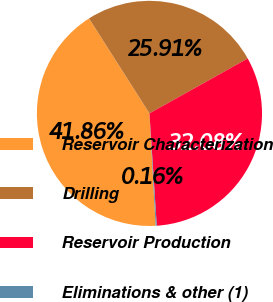<chart> <loc_0><loc_0><loc_500><loc_500><pie_chart><fcel>Reservoir Characterization<fcel>Drilling<fcel>Reservoir Production<fcel>Eliminations & other (1)<nl><fcel>41.86%<fcel>25.91%<fcel>32.08%<fcel>0.16%<nl></chart> 